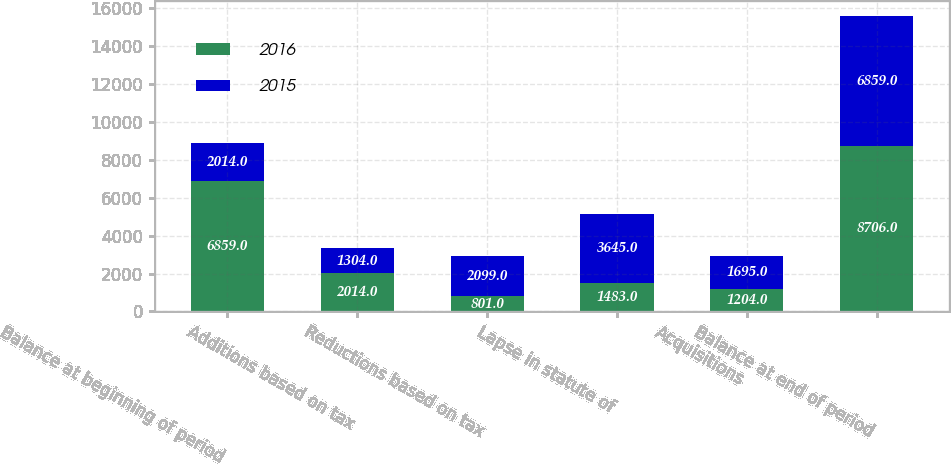Convert chart. <chart><loc_0><loc_0><loc_500><loc_500><stacked_bar_chart><ecel><fcel>Balance at beginning of period<fcel>Additions based on tax<fcel>Reductions based on tax<fcel>Lapse in statute of<fcel>Acquisitions<fcel>Balance at end of period<nl><fcel>2016<fcel>6859<fcel>2014<fcel>801<fcel>1483<fcel>1204<fcel>8706<nl><fcel>2015<fcel>2014<fcel>1304<fcel>2099<fcel>3645<fcel>1695<fcel>6859<nl></chart> 